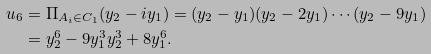<formula> <loc_0><loc_0><loc_500><loc_500>u _ { 6 } & = \Pi _ { A _ { i } \in C _ { 1 } } ( y _ { 2 } - i y _ { 1 } ) = ( y _ { 2 } - y _ { 1 } ) ( y _ { 2 } - 2 y _ { 1 } ) \cdots ( y _ { 2 } - 9 y _ { 1 } ) \\ & = y _ { 2 } ^ { 6 } - 9 y _ { 1 } ^ { 3 } y _ { 2 } ^ { 3 } + 8 y _ { 1 } ^ { 6 } .</formula> 